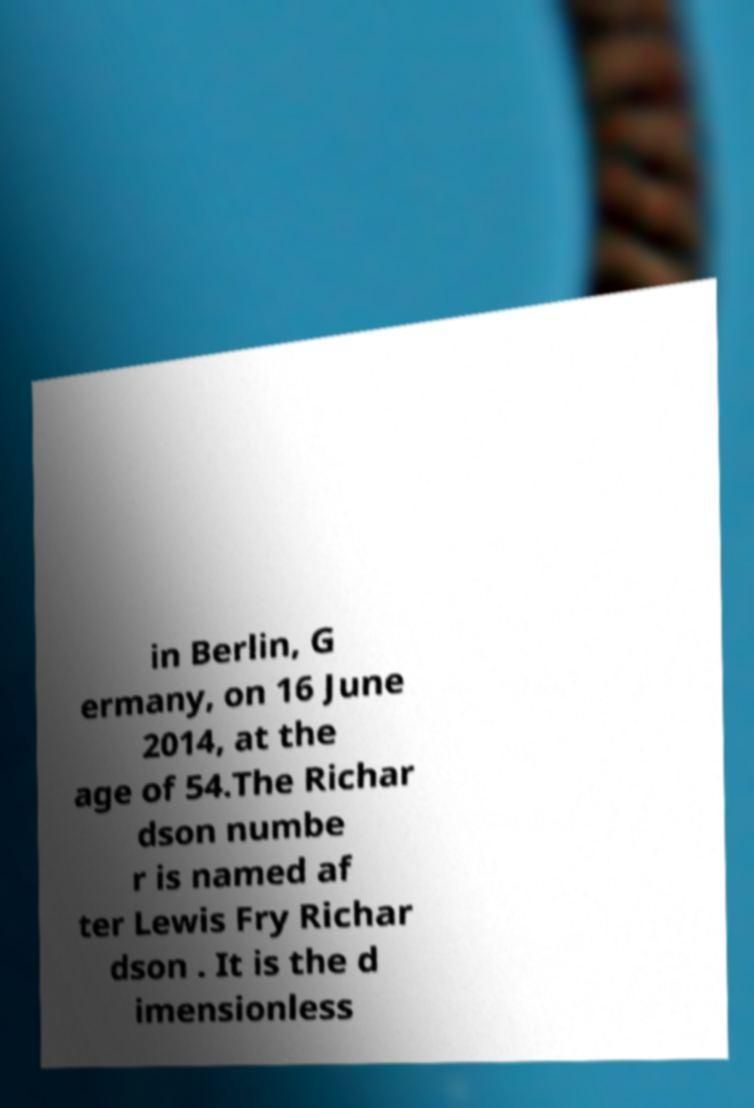Could you extract and type out the text from this image? in Berlin, G ermany, on 16 June 2014, at the age of 54.The Richar dson numbe r is named af ter Lewis Fry Richar dson . It is the d imensionless 